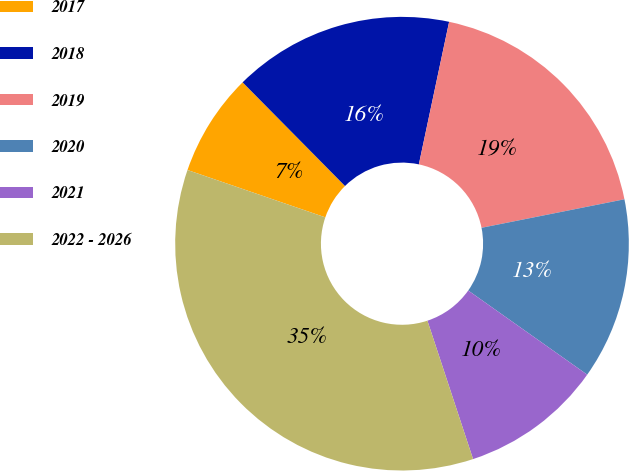Convert chart. <chart><loc_0><loc_0><loc_500><loc_500><pie_chart><fcel>2017<fcel>2018<fcel>2019<fcel>2020<fcel>2021<fcel>2022 - 2026<nl><fcel>7.33%<fcel>15.73%<fcel>18.53%<fcel>12.93%<fcel>10.13%<fcel>35.33%<nl></chart> 